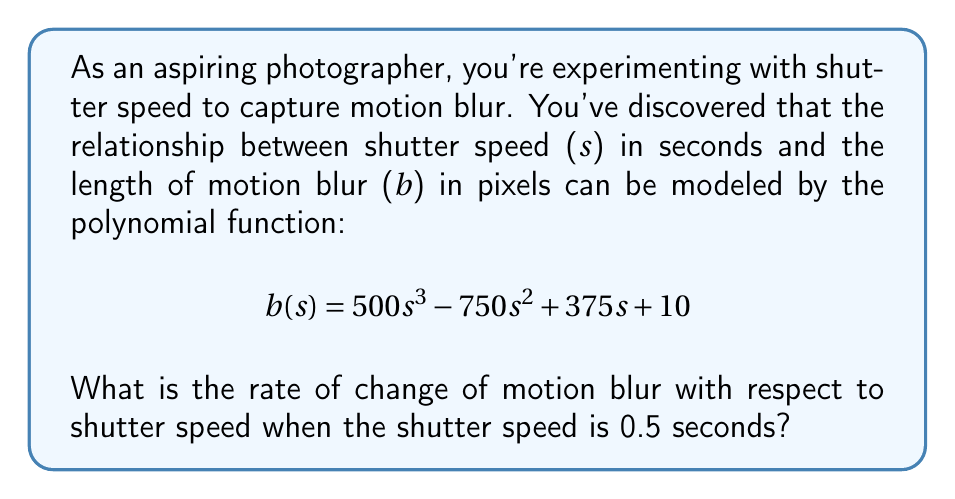Help me with this question. To find the rate of change of motion blur with respect to shutter speed, we need to calculate the derivative of the given function $b(s)$ and then evaluate it at $s = 0.5$.

Step 1: Find the derivative of $b(s)$.
$$b(s) = 500s^3 - 750s^2 + 375s + 10$$
$$\frac{db}{ds} = 1500s^2 - 1500s + 375$$

Step 2: Evaluate the derivative at $s = 0.5$.
$$\frac{db}{ds}\bigg|_{s=0.5} = 1500(0.5)^2 - 1500(0.5) + 375$$
$$= 1500(0.25) - 750 + 375$$
$$= 375 - 750 + 375$$
$$= 0$$

Therefore, the rate of change of motion blur with respect to shutter speed when the shutter speed is 0.5 seconds is 0 pixels per second.
Answer: 0 pixels/second 